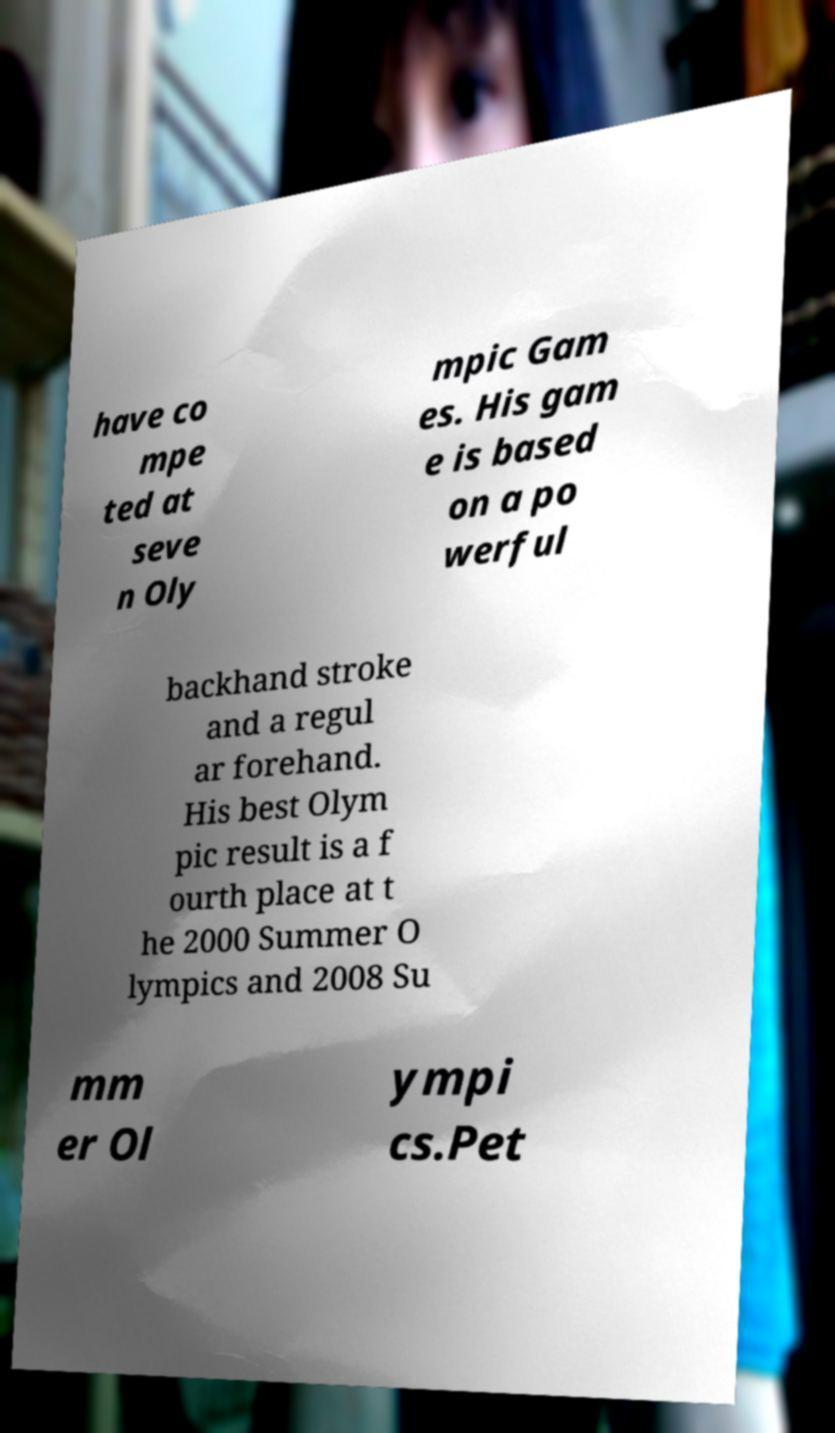Please identify and transcribe the text found in this image. have co mpe ted at seve n Oly mpic Gam es. His gam e is based on a po werful backhand stroke and a regul ar forehand. His best Olym pic result is a f ourth place at t he 2000 Summer O lympics and 2008 Su mm er Ol ympi cs.Pet 